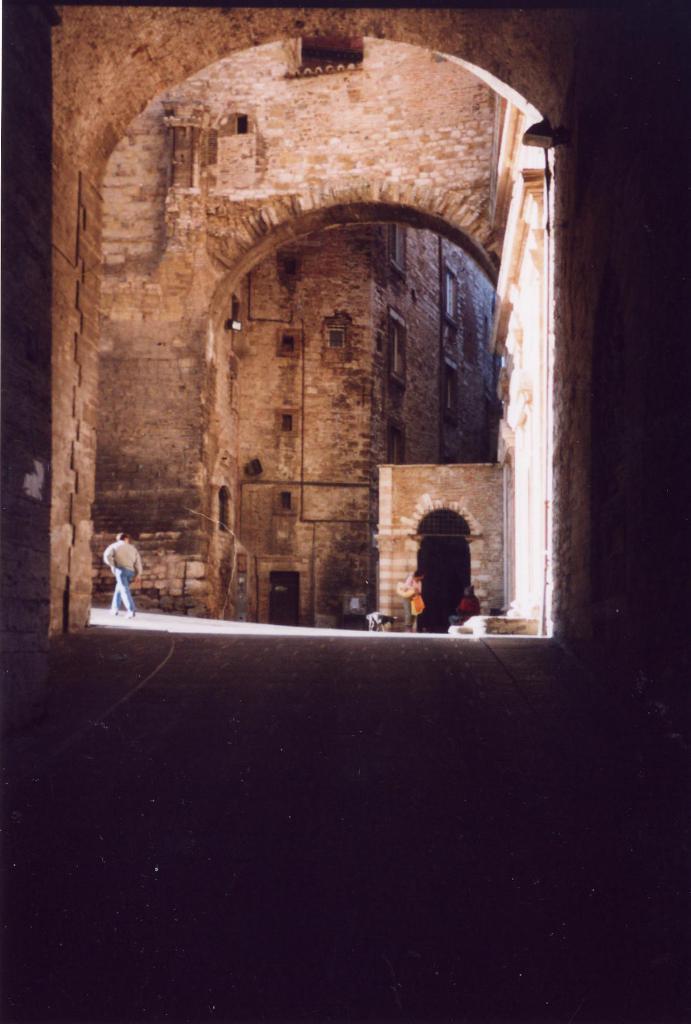Can you describe this image briefly? In this image I can see a person walking wearing brown shirt, blue pant. Background I can see a building in brown color. 